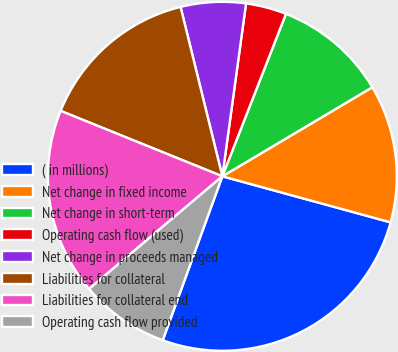<chart> <loc_0><loc_0><loc_500><loc_500><pie_chart><fcel>( in millions)<fcel>Net change in fixed income<fcel>Net change in short-term<fcel>Operating cash flow (used)<fcel>Net change in proceeds managed<fcel>Liabilities for collateral<fcel>Liabilities for collateral end<fcel>Operating cash flow provided<nl><fcel>26.3%<fcel>12.78%<fcel>10.53%<fcel>3.77%<fcel>6.02%<fcel>15.03%<fcel>17.29%<fcel>8.28%<nl></chart> 